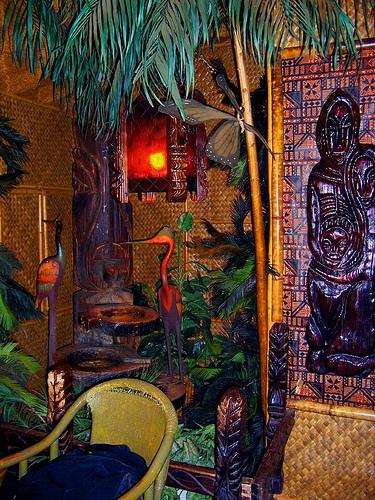Can you describe the types of materials used in the decor? Certainly, the decoration prominently features natural and rustic materials, such as bamboo for the chair and possibly the wall coverings, woven grass or palm for the thatched elements, wood for the carved statues, and fabrics with tribal or tropical prints for added accent. 